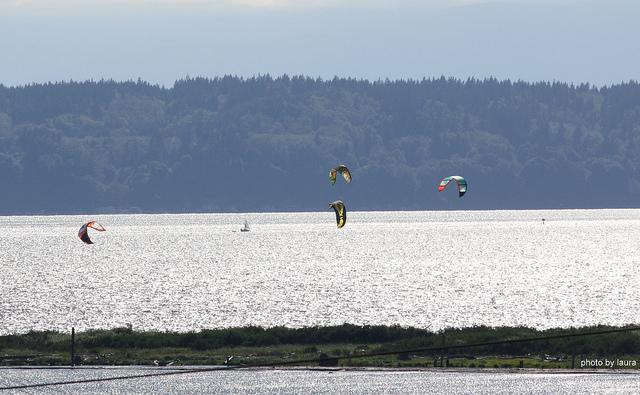Is there a boat in the scene?
Quick response, please. Yes. What is in the background?
Keep it brief. Trees. Are those birds?
Be succinct. No. 